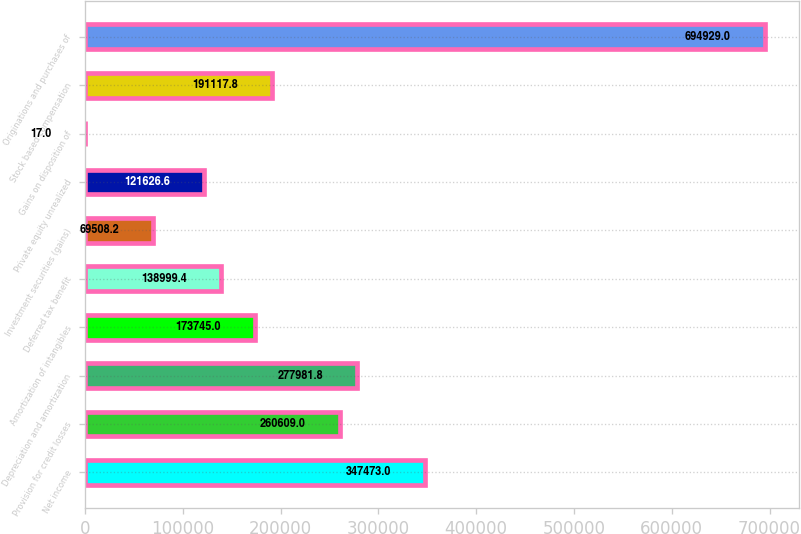Convert chart. <chart><loc_0><loc_0><loc_500><loc_500><bar_chart><fcel>Net income<fcel>Provision for credit losses<fcel>Depreciation and amortization<fcel>Amortization of intangibles<fcel>Deferred tax benefit<fcel>Investment securities (gains)<fcel>Private equity unrealized<fcel>Gains on disposition of<fcel>Stock based compensation<fcel>Originations and purchases of<nl><fcel>347473<fcel>260609<fcel>277982<fcel>173745<fcel>138999<fcel>69508.2<fcel>121627<fcel>17<fcel>191118<fcel>694929<nl></chart> 